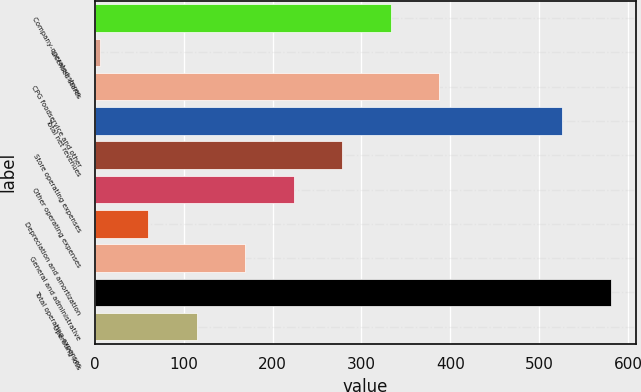Convert chart. <chart><loc_0><loc_0><loc_500><loc_500><bar_chart><fcel>Company-operated stores<fcel>Licensed stores<fcel>CPG foodservice and other<fcel>Total net revenues<fcel>Store operating expenses<fcel>Other operating expenses<fcel>Depreciation and amortization<fcel>General and administrative<fcel>Total operating expenses<fcel>Operating loss<nl><fcel>332.72<fcel>5.9<fcel>387.19<fcel>525.8<fcel>278.25<fcel>223.78<fcel>60.37<fcel>169.31<fcel>580.27<fcel>114.84<nl></chart> 